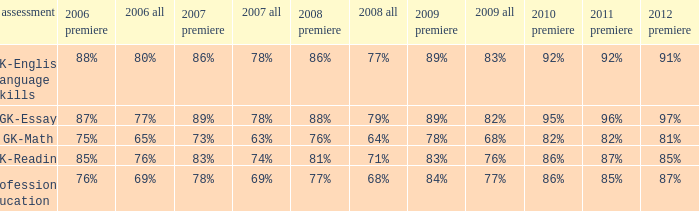What is the percentage for all in 2007 when all in 2006 was 65%? 63%. 